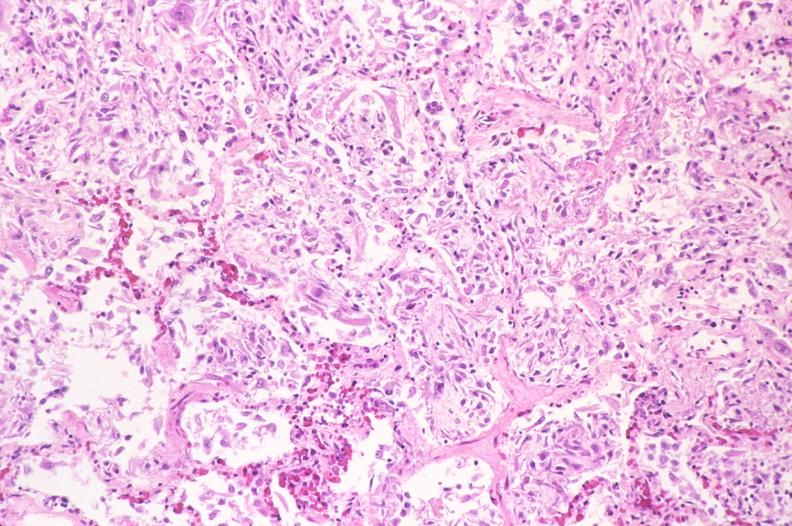does hypopharyngeal edema show lung, diffuse alveolar damage?
Answer the question using a single word or phrase. No 